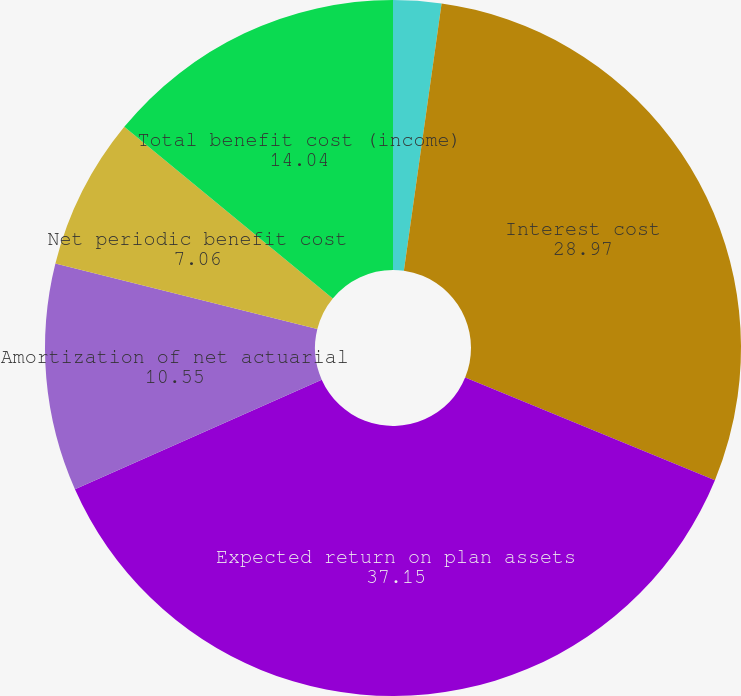Convert chart to OTSL. <chart><loc_0><loc_0><loc_500><loc_500><pie_chart><fcel>Service cost<fcel>Interest cost<fcel>Expected return on plan assets<fcel>Amortization of net actuarial<fcel>Net periodic benefit cost<fcel>Total benefit cost (income)<nl><fcel>2.23%<fcel>28.97%<fcel>37.15%<fcel>10.55%<fcel>7.06%<fcel>14.04%<nl></chart> 